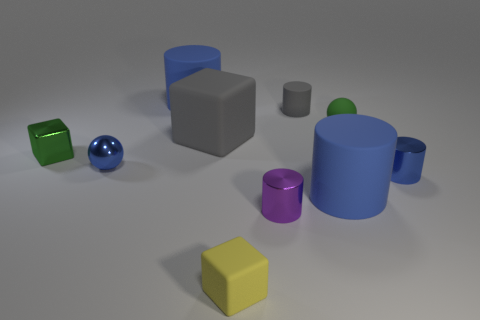How many blue cylinders must be subtracted to get 1 blue cylinders? 2 Subtract all red blocks. How many blue cylinders are left? 3 Subtract 1 cylinders. How many cylinders are left? 4 Subtract all cyan cylinders. Subtract all gray balls. How many cylinders are left? 5 Subtract all spheres. How many objects are left? 8 Add 2 cyan rubber cubes. How many cyan rubber cubes exist? 2 Subtract 0 brown blocks. How many objects are left? 10 Subtract all tiny gray cylinders. Subtract all large blue cylinders. How many objects are left? 7 Add 3 yellow rubber objects. How many yellow rubber objects are left? 4 